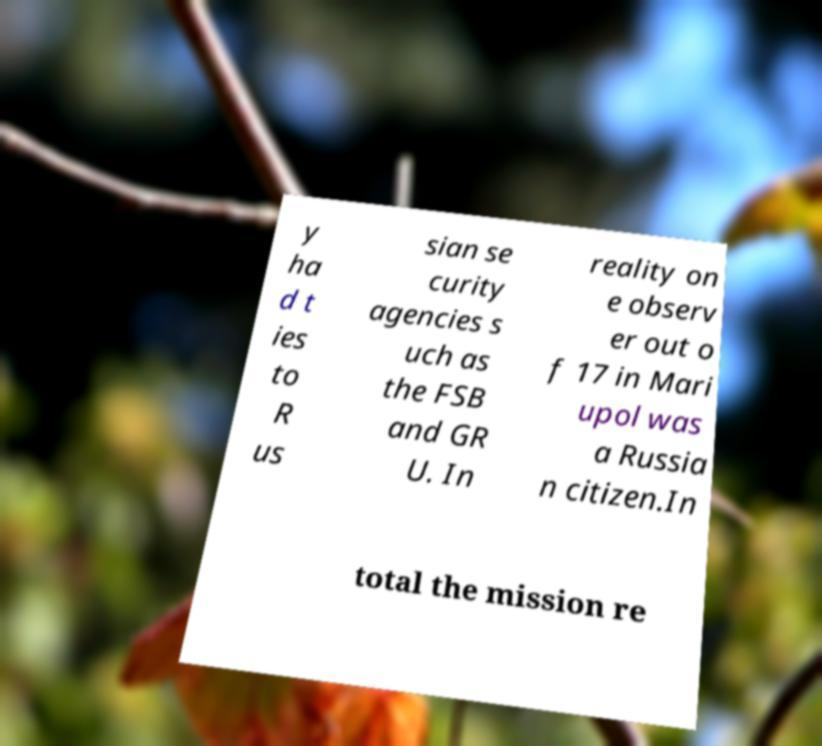Could you extract and type out the text from this image? y ha d t ies to R us sian se curity agencies s uch as the FSB and GR U. In reality on e observ er out o f 17 in Mari upol was a Russia n citizen.In total the mission re 